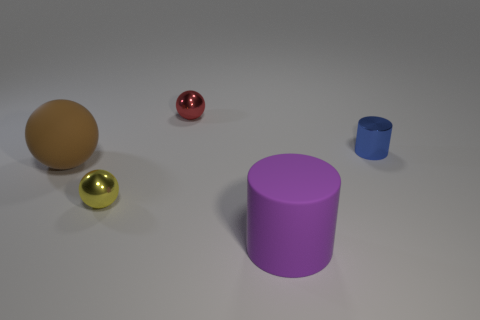Subtract all small spheres. How many spheres are left? 1 Subtract all purple cylinders. How many cylinders are left? 1 Subtract all spheres. How many objects are left? 2 Add 2 brown things. How many objects exist? 7 Subtract all blue balls. How many blue cylinders are left? 1 Subtract all blue cylinders. Subtract all small red things. How many objects are left? 3 Add 1 large rubber spheres. How many large rubber spheres are left? 2 Add 5 small metallic balls. How many small metallic balls exist? 7 Subtract 1 purple cylinders. How many objects are left? 4 Subtract all brown cylinders. Subtract all blue balls. How many cylinders are left? 2 